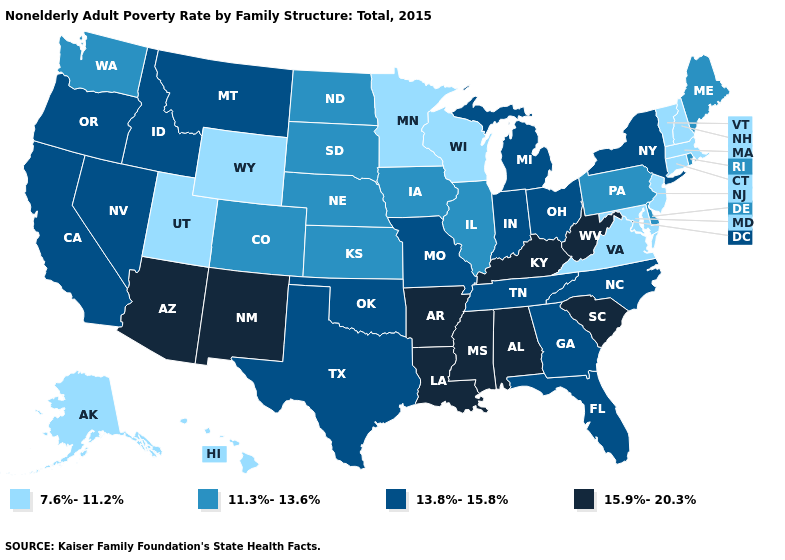What is the value of Texas?
Be succinct. 13.8%-15.8%. What is the lowest value in the USA?
Keep it brief. 7.6%-11.2%. Which states have the lowest value in the USA?
Write a very short answer. Alaska, Connecticut, Hawaii, Maryland, Massachusetts, Minnesota, New Hampshire, New Jersey, Utah, Vermont, Virginia, Wisconsin, Wyoming. What is the highest value in the USA?
Concise answer only. 15.9%-20.3%. Which states have the highest value in the USA?
Keep it brief. Alabama, Arizona, Arkansas, Kentucky, Louisiana, Mississippi, New Mexico, South Carolina, West Virginia. Name the states that have a value in the range 7.6%-11.2%?
Short answer required. Alaska, Connecticut, Hawaii, Maryland, Massachusetts, Minnesota, New Hampshire, New Jersey, Utah, Vermont, Virginia, Wisconsin, Wyoming. What is the value of Alaska?
Quick response, please. 7.6%-11.2%. Name the states that have a value in the range 7.6%-11.2%?
Keep it brief. Alaska, Connecticut, Hawaii, Maryland, Massachusetts, Minnesota, New Hampshire, New Jersey, Utah, Vermont, Virginia, Wisconsin, Wyoming. Does California have a lower value than Alaska?
Keep it brief. No. How many symbols are there in the legend?
Concise answer only. 4. Name the states that have a value in the range 13.8%-15.8%?
Concise answer only. California, Florida, Georgia, Idaho, Indiana, Michigan, Missouri, Montana, Nevada, New York, North Carolina, Ohio, Oklahoma, Oregon, Tennessee, Texas. Which states hav the highest value in the Northeast?
Be succinct. New York. What is the value of Minnesota?
Quick response, please. 7.6%-11.2%. Does Oregon have a lower value than Alabama?
Answer briefly. Yes. Is the legend a continuous bar?
Short answer required. No. 